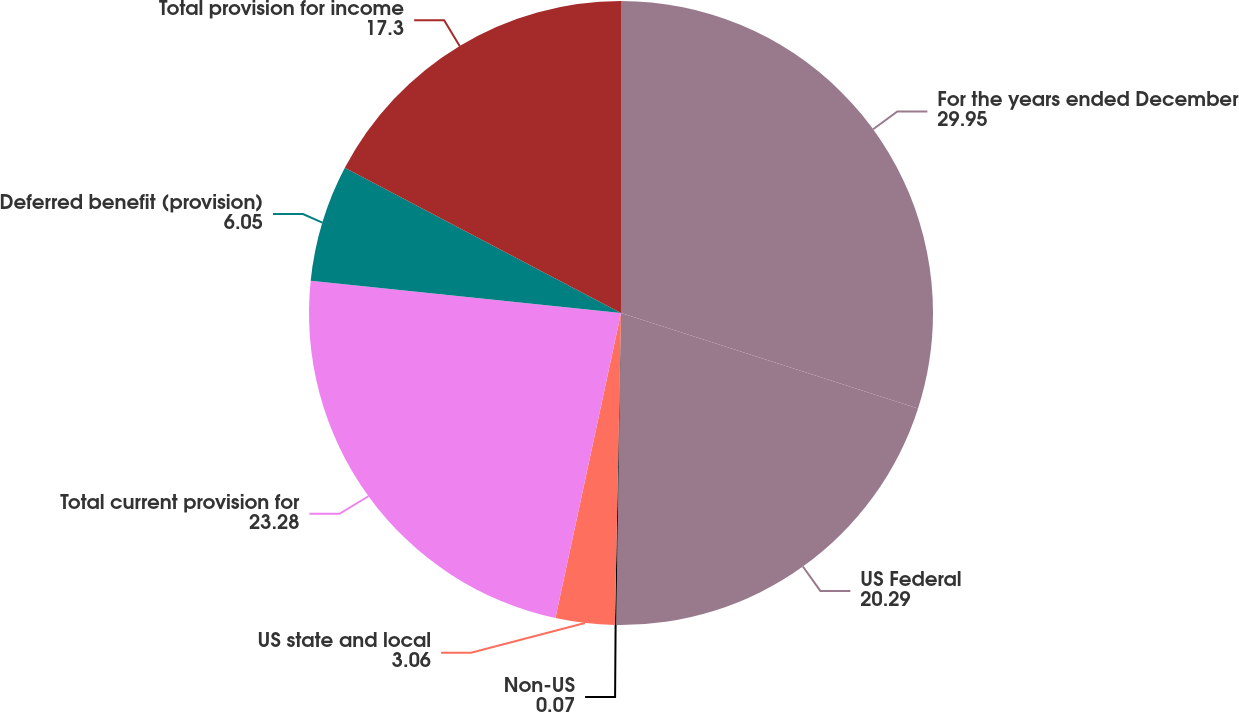<chart> <loc_0><loc_0><loc_500><loc_500><pie_chart><fcel>For the years ended December<fcel>US Federal<fcel>Non-US<fcel>US state and local<fcel>Total current provision for<fcel>Deferred benefit (provision)<fcel>Total provision for income<nl><fcel>29.95%<fcel>20.29%<fcel>0.07%<fcel>3.06%<fcel>23.28%<fcel>6.05%<fcel>17.3%<nl></chart> 